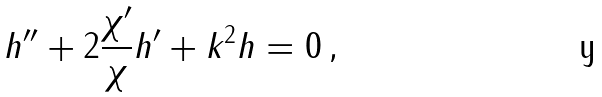Convert formula to latex. <formula><loc_0><loc_0><loc_500><loc_500>h ^ { \prime \prime } + 2 \frac { \chi ^ { \prime } } { \chi } h ^ { \prime } + k ^ { 2 } h = 0 \, ,</formula> 